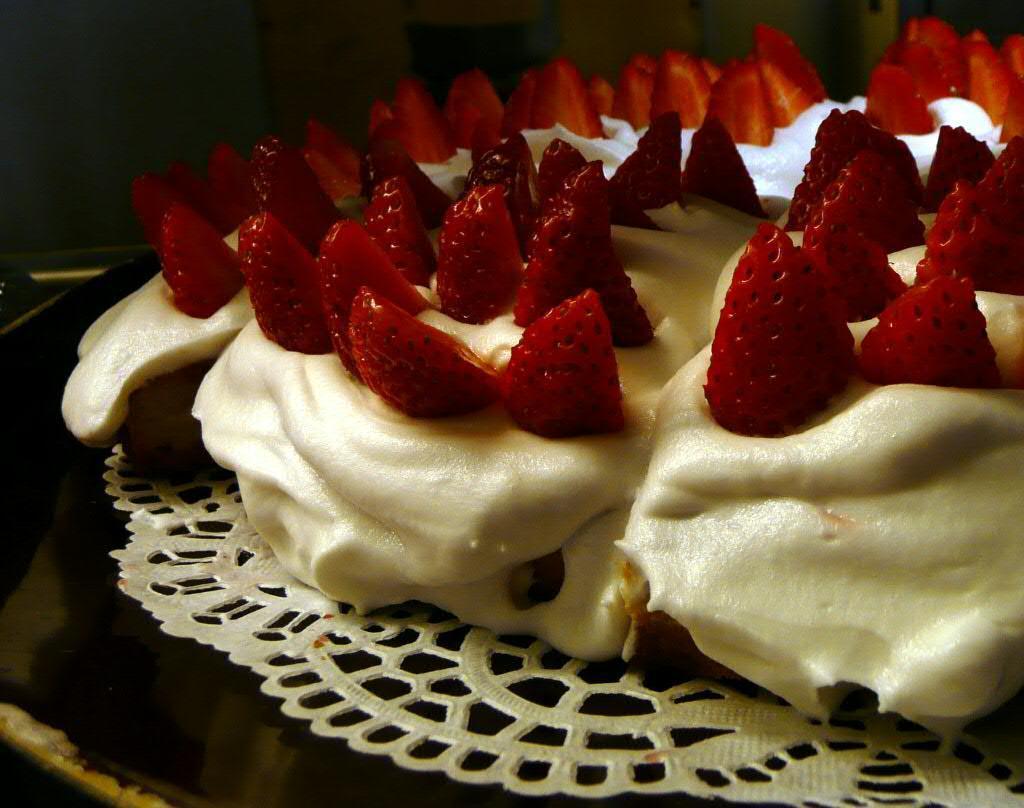Could you give a brief overview of what you see in this image? In this image we can see strawberries on top of the cream which was placed on the table. 